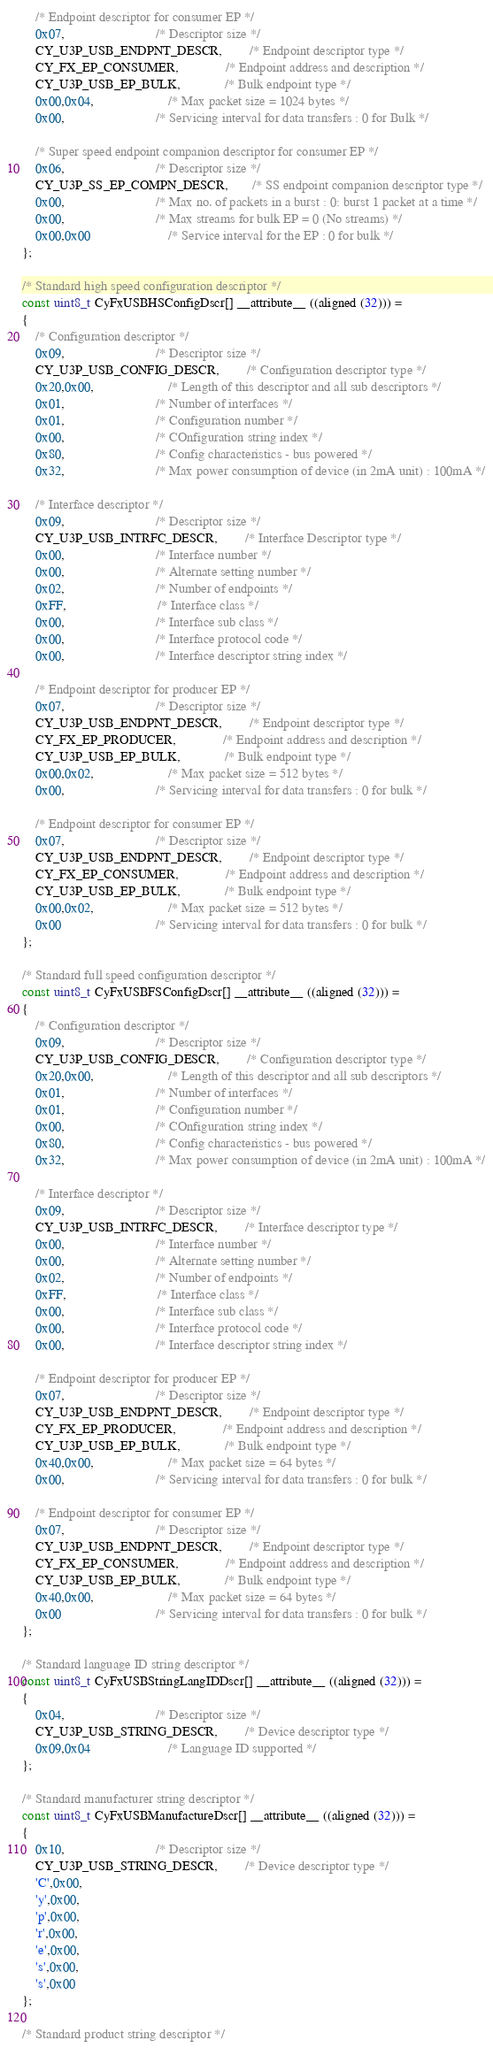<code> <loc_0><loc_0><loc_500><loc_500><_C_>
    /* Endpoint descriptor for consumer EP */
    0x07,                           /* Descriptor size */
    CY_U3P_USB_ENDPNT_DESCR,        /* Endpoint descriptor type */
    CY_FX_EP_CONSUMER,              /* Endpoint address and description */
    CY_U3P_USB_EP_BULK,             /* Bulk endpoint type */
    0x00,0x04,                      /* Max packet size = 1024 bytes */
    0x00,                           /* Servicing interval for data transfers : 0 for Bulk */

    /* Super speed endpoint companion descriptor for consumer EP */
    0x06,                           /* Descriptor size */
    CY_U3P_SS_EP_COMPN_DESCR,       /* SS endpoint companion descriptor type */
    0x00,                           /* Max no. of packets in a burst : 0: burst 1 packet at a time */
    0x00,                           /* Max streams for bulk EP = 0 (No streams) */
    0x00,0x00                       /* Service interval for the EP : 0 for bulk */
};

/* Standard high speed configuration descriptor */
const uint8_t CyFxUSBHSConfigDscr[] __attribute__ ((aligned (32))) =
{
    /* Configuration descriptor */
    0x09,                           /* Descriptor size */
    CY_U3P_USB_CONFIG_DESCR,        /* Configuration descriptor type */
    0x20,0x00,                      /* Length of this descriptor and all sub descriptors */
    0x01,                           /* Number of interfaces */
    0x01,                           /* Configuration number */
    0x00,                           /* COnfiguration string index */
    0x80,                           /* Config characteristics - bus powered */
    0x32,                           /* Max power consumption of device (in 2mA unit) : 100mA */

    /* Interface descriptor */
    0x09,                           /* Descriptor size */
    CY_U3P_USB_INTRFC_DESCR,        /* Interface Descriptor type */
    0x00,                           /* Interface number */
    0x00,                           /* Alternate setting number */
    0x02,                           /* Number of endpoints */
    0xFF,                           /* Interface class */
    0x00,                           /* Interface sub class */
    0x00,                           /* Interface protocol code */
    0x00,                           /* Interface descriptor string index */

    /* Endpoint descriptor for producer EP */
    0x07,                           /* Descriptor size */
    CY_U3P_USB_ENDPNT_DESCR,        /* Endpoint descriptor type */
    CY_FX_EP_PRODUCER,              /* Endpoint address and description */
    CY_U3P_USB_EP_BULK,             /* Bulk endpoint type */
    0x00,0x02,                      /* Max packet size = 512 bytes */
    0x00,                           /* Servicing interval for data transfers : 0 for bulk */

    /* Endpoint descriptor for consumer EP */
    0x07,                           /* Descriptor size */
    CY_U3P_USB_ENDPNT_DESCR,        /* Endpoint descriptor type */
    CY_FX_EP_CONSUMER,              /* Endpoint address and description */
    CY_U3P_USB_EP_BULK,             /* Bulk endpoint type */
    0x00,0x02,                      /* Max packet size = 512 bytes */
    0x00                            /* Servicing interval for data transfers : 0 for bulk */
};

/* Standard full speed configuration descriptor */
const uint8_t CyFxUSBFSConfigDscr[] __attribute__ ((aligned (32))) =
{
    /* Configuration descriptor */
    0x09,                           /* Descriptor size */
    CY_U3P_USB_CONFIG_DESCR,        /* Configuration descriptor type */
    0x20,0x00,                      /* Length of this descriptor and all sub descriptors */
    0x01,                           /* Number of interfaces */
    0x01,                           /* Configuration number */
    0x00,                           /* COnfiguration string index */
    0x80,                           /* Config characteristics - bus powered */
    0x32,                           /* Max power consumption of device (in 2mA unit) : 100mA */

    /* Interface descriptor */
    0x09,                           /* Descriptor size */
    CY_U3P_USB_INTRFC_DESCR,        /* Interface descriptor type */
    0x00,                           /* Interface number */
    0x00,                           /* Alternate setting number */
    0x02,                           /* Number of endpoints */
    0xFF,                           /* Interface class */
    0x00,                           /* Interface sub class */
    0x00,                           /* Interface protocol code */
    0x00,                           /* Interface descriptor string index */

    /* Endpoint descriptor for producer EP */
    0x07,                           /* Descriptor size */
    CY_U3P_USB_ENDPNT_DESCR,        /* Endpoint descriptor type */
    CY_FX_EP_PRODUCER,              /* Endpoint address and description */
    CY_U3P_USB_EP_BULK,             /* Bulk endpoint type */
    0x40,0x00,                      /* Max packet size = 64 bytes */
    0x00,                           /* Servicing interval for data transfers : 0 for bulk */

    /* Endpoint descriptor for consumer EP */
    0x07,                           /* Descriptor size */
    CY_U3P_USB_ENDPNT_DESCR,        /* Endpoint descriptor type */
    CY_FX_EP_CONSUMER,              /* Endpoint address and description */
    CY_U3P_USB_EP_BULK,             /* Bulk endpoint type */
    0x40,0x00,                      /* Max packet size = 64 bytes */
    0x00                            /* Servicing interval for data transfers : 0 for bulk */
};

/* Standard language ID string descriptor */
const uint8_t CyFxUSBStringLangIDDscr[] __attribute__ ((aligned (32))) =
{
    0x04,                           /* Descriptor size */
    CY_U3P_USB_STRING_DESCR,        /* Device descriptor type */
    0x09,0x04                       /* Language ID supported */
};

/* Standard manufacturer string descriptor */
const uint8_t CyFxUSBManufactureDscr[] __attribute__ ((aligned (32))) =
{
    0x10,                           /* Descriptor size */
    CY_U3P_USB_STRING_DESCR,        /* Device descriptor type */
    'C',0x00,
    'y',0x00,
    'p',0x00,
    'r',0x00,
    'e',0x00,
    's',0x00,
    's',0x00
};

/* Standard product string descriptor */</code> 